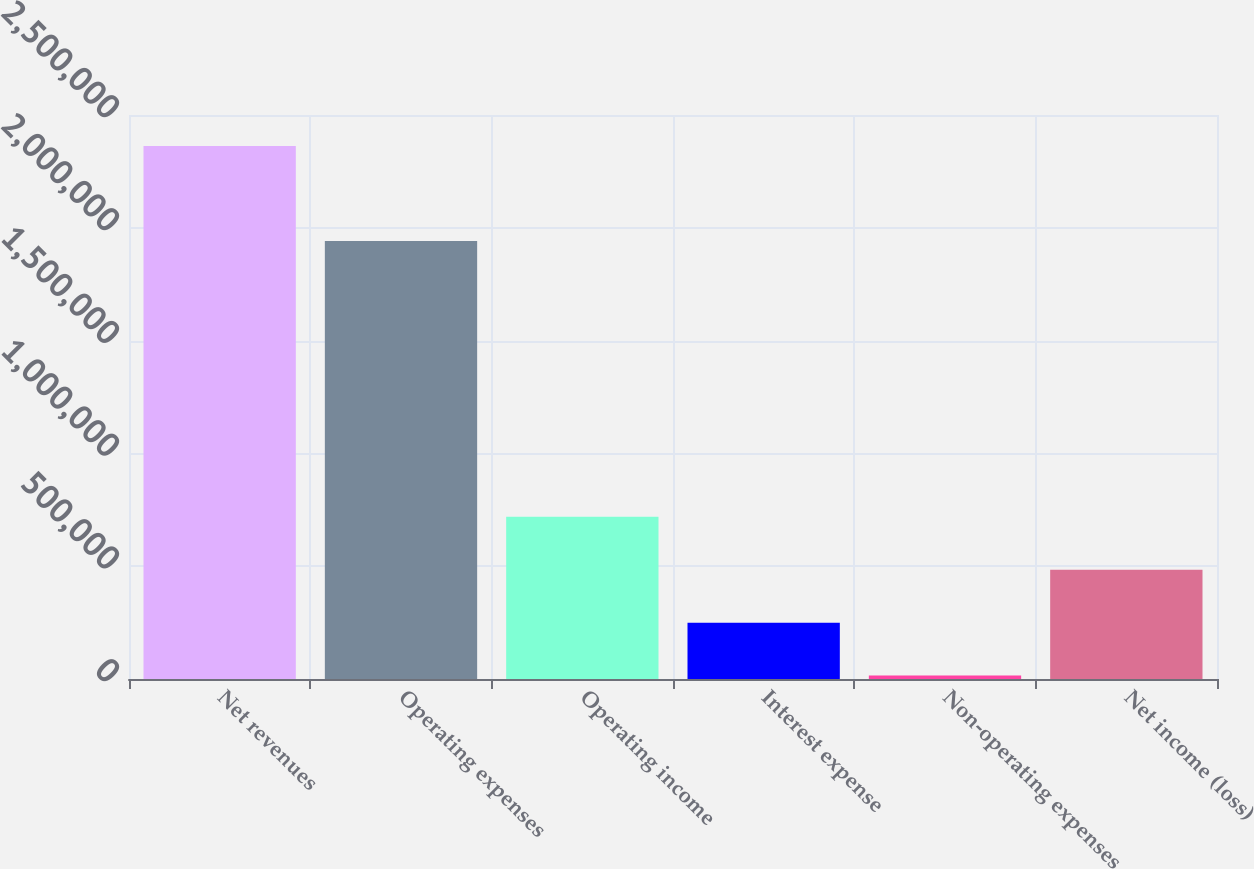<chart> <loc_0><loc_0><loc_500><loc_500><bar_chart><fcel>Net revenues<fcel>Operating expenses<fcel>Operating income<fcel>Interest expense<fcel>Non-operating expenses<fcel>Net income (loss)<nl><fcel>2.36226e+06<fcel>1.94181e+06<fcel>719248<fcel>249817<fcel>15101<fcel>484532<nl></chart> 